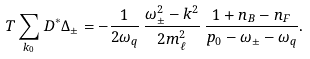<formula> <loc_0><loc_0><loc_500><loc_500>T \sum _ { k _ { 0 } } D ^ { * } \Delta _ { \pm } = - \frac { 1 } { 2 \omega _ { q } } \, \frac { \omega _ { \pm } ^ { 2 } - k ^ { 2 } } { 2 m _ { \ell } ^ { 2 } } \, \frac { 1 + n _ { B } - n _ { F } } { p _ { 0 } - \omega _ { \pm } - \omega _ { q } } .</formula> 